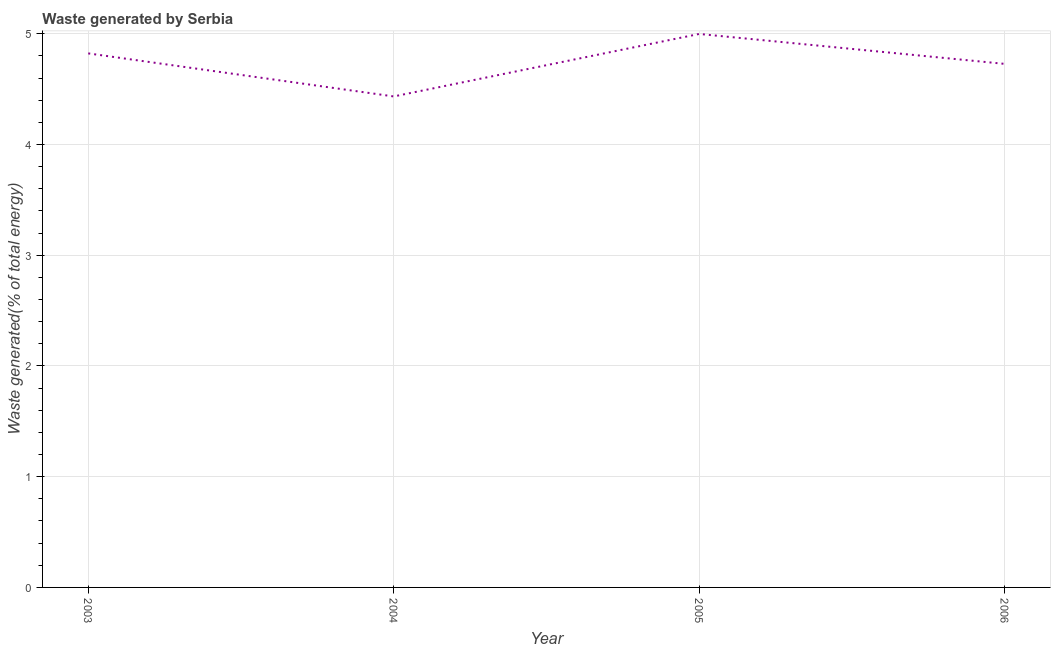What is the amount of waste generated in 2006?
Make the answer very short. 4.73. Across all years, what is the maximum amount of waste generated?
Give a very brief answer. 5. Across all years, what is the minimum amount of waste generated?
Offer a very short reply. 4.43. In which year was the amount of waste generated maximum?
Offer a very short reply. 2005. What is the sum of the amount of waste generated?
Your response must be concise. 18.99. What is the difference between the amount of waste generated in 2004 and 2005?
Offer a very short reply. -0.56. What is the average amount of waste generated per year?
Your response must be concise. 4.75. What is the median amount of waste generated?
Provide a short and direct response. 4.78. In how many years, is the amount of waste generated greater than 4.8 %?
Your answer should be very brief. 2. Do a majority of the years between 2006 and 2003 (inclusive) have amount of waste generated greater than 4.2 %?
Offer a terse response. Yes. What is the ratio of the amount of waste generated in 2005 to that in 2006?
Keep it short and to the point. 1.06. Is the difference between the amount of waste generated in 2004 and 2006 greater than the difference between any two years?
Provide a succinct answer. No. What is the difference between the highest and the second highest amount of waste generated?
Make the answer very short. 0.18. What is the difference between the highest and the lowest amount of waste generated?
Give a very brief answer. 0.56. In how many years, is the amount of waste generated greater than the average amount of waste generated taken over all years?
Your answer should be very brief. 2. How many lines are there?
Give a very brief answer. 1. What is the difference between two consecutive major ticks on the Y-axis?
Provide a succinct answer. 1. Does the graph contain any zero values?
Make the answer very short. No. Does the graph contain grids?
Ensure brevity in your answer.  Yes. What is the title of the graph?
Make the answer very short. Waste generated by Serbia. What is the label or title of the X-axis?
Your answer should be compact. Year. What is the label or title of the Y-axis?
Make the answer very short. Waste generated(% of total energy). What is the Waste generated(% of total energy) in 2003?
Offer a terse response. 4.82. What is the Waste generated(% of total energy) in 2004?
Give a very brief answer. 4.43. What is the Waste generated(% of total energy) of 2005?
Make the answer very short. 5. What is the Waste generated(% of total energy) of 2006?
Ensure brevity in your answer.  4.73. What is the difference between the Waste generated(% of total energy) in 2003 and 2004?
Provide a succinct answer. 0.39. What is the difference between the Waste generated(% of total energy) in 2003 and 2005?
Keep it short and to the point. -0.18. What is the difference between the Waste generated(% of total energy) in 2003 and 2006?
Provide a succinct answer. 0.09. What is the difference between the Waste generated(% of total energy) in 2004 and 2005?
Make the answer very short. -0.56. What is the difference between the Waste generated(% of total energy) in 2004 and 2006?
Your answer should be very brief. -0.29. What is the difference between the Waste generated(% of total energy) in 2005 and 2006?
Your answer should be compact. 0.27. What is the ratio of the Waste generated(% of total energy) in 2003 to that in 2004?
Provide a succinct answer. 1.09. What is the ratio of the Waste generated(% of total energy) in 2003 to that in 2006?
Provide a short and direct response. 1.02. What is the ratio of the Waste generated(% of total energy) in 2004 to that in 2005?
Provide a short and direct response. 0.89. What is the ratio of the Waste generated(% of total energy) in 2004 to that in 2006?
Keep it short and to the point. 0.94. What is the ratio of the Waste generated(% of total energy) in 2005 to that in 2006?
Provide a succinct answer. 1.06. 